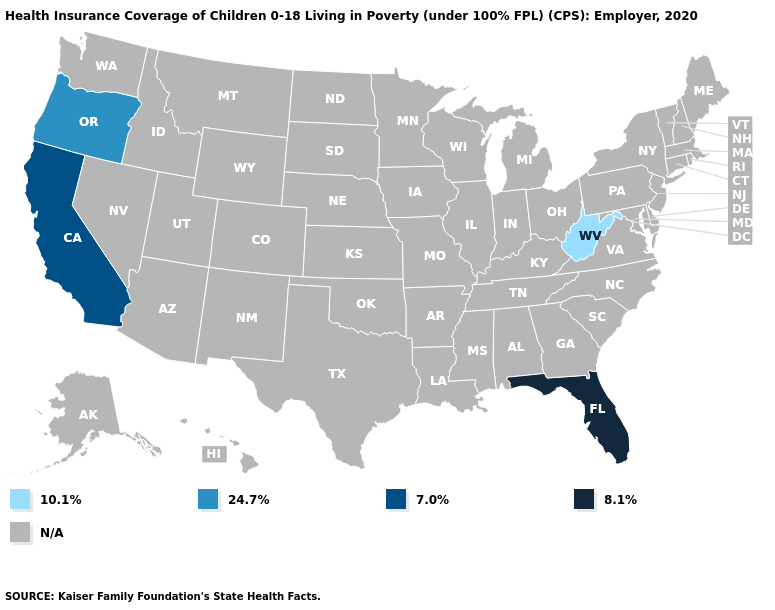Which states hav the highest value in the West?
Quick response, please. California. What is the value of Vermont?
Answer briefly. N/A. Which states have the lowest value in the South?
Write a very short answer. West Virginia. Does Oregon have the highest value in the USA?
Be succinct. No. Among the states that border Nevada , does California have the highest value?
Short answer required. Yes. How many symbols are there in the legend?
Short answer required. 5. Name the states that have a value in the range 10.1%?
Quick response, please. West Virginia. 